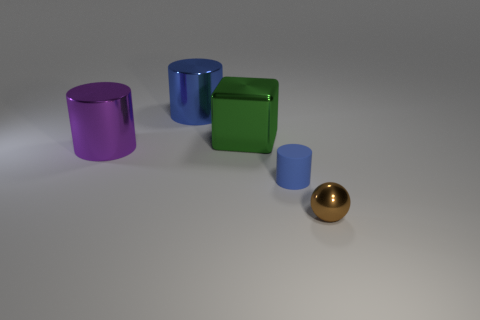Is there anything else that has the same shape as the green object?
Keep it short and to the point. No. There is a cylinder that is right of the blue thing that is behind the tiny blue thing; how big is it?
Your answer should be compact. Small. Is there a blue thing of the same size as the brown ball?
Make the answer very short. Yes. There is a blue cylinder right of the big blue shiny cylinder; does it have the same size as the metal cylinder on the left side of the large blue metallic thing?
Make the answer very short. No. What is the shape of the metallic thing that is in front of the thing to the left of the big blue cylinder?
Provide a short and direct response. Sphere. How many shiny balls are left of the large green shiny cube?
Give a very brief answer. 0. What color is the sphere that is made of the same material as the large cube?
Give a very brief answer. Brown. Does the shiny cube have the same size as the blue object that is in front of the big purple shiny thing?
Ensure brevity in your answer.  No. What is the size of the thing to the right of the tiny object left of the shiny object in front of the small blue matte object?
Offer a terse response. Small. What number of matte objects are either small blue cylinders or cyan blocks?
Keep it short and to the point. 1. 